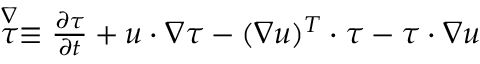Convert formula to latex. <formula><loc_0><loc_0><loc_500><loc_500>\begin{array} { r } { \stackrel { \nabla } { \tau } \equiv \frac { \partial \tau } { \partial t } + u \cdot \nabla \tau - ( \nabla u ) ^ { T } \cdot \tau - \tau \cdot \nabla u } \end{array}</formula> 